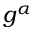Convert formula to latex. <formula><loc_0><loc_0><loc_500><loc_500>g ^ { \alpha }</formula> 